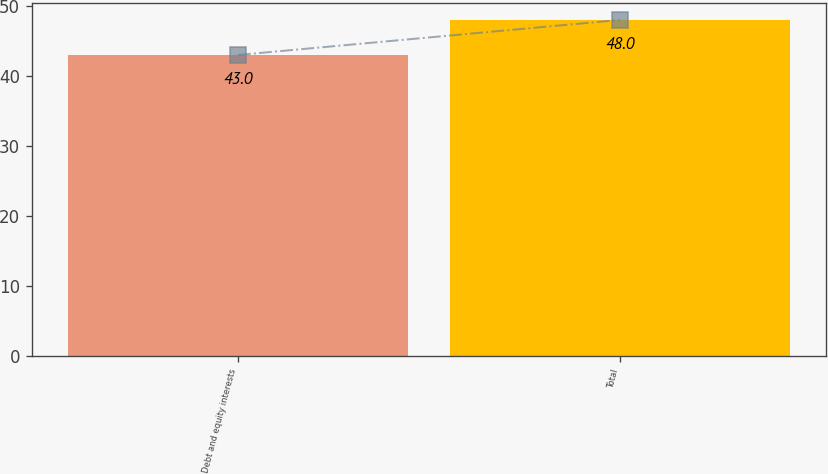<chart> <loc_0><loc_0><loc_500><loc_500><bar_chart><fcel>Debt and equity interests<fcel>Total<nl><fcel>43<fcel>48<nl></chart> 